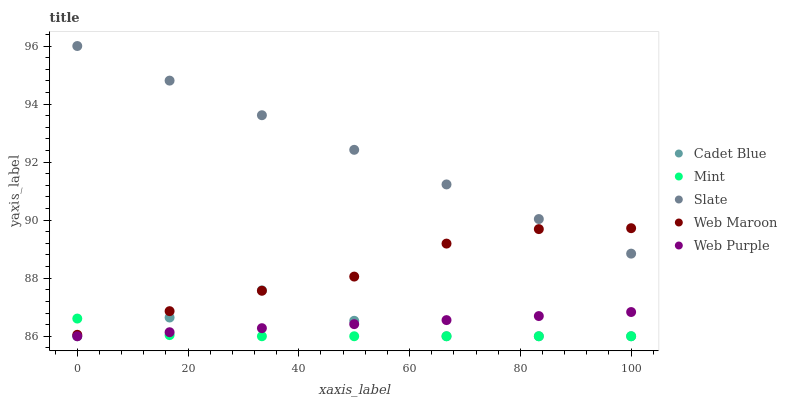Does Mint have the minimum area under the curve?
Answer yes or no. Yes. Does Slate have the maximum area under the curve?
Answer yes or no. Yes. Does Cadet Blue have the minimum area under the curve?
Answer yes or no. No. Does Cadet Blue have the maximum area under the curve?
Answer yes or no. No. Is Slate the smoothest?
Answer yes or no. Yes. Is Cadet Blue the roughest?
Answer yes or no. Yes. Is Cadet Blue the smoothest?
Answer yes or no. No. Is Slate the roughest?
Answer yes or no. No. Does Cadet Blue have the lowest value?
Answer yes or no. Yes. Does Slate have the lowest value?
Answer yes or no. No. Does Slate have the highest value?
Answer yes or no. Yes. Does Cadet Blue have the highest value?
Answer yes or no. No. Is Mint less than Slate?
Answer yes or no. Yes. Is Slate greater than Mint?
Answer yes or no. Yes. Does Cadet Blue intersect Web Purple?
Answer yes or no. Yes. Is Cadet Blue less than Web Purple?
Answer yes or no. No. Is Cadet Blue greater than Web Purple?
Answer yes or no. No. Does Mint intersect Slate?
Answer yes or no. No. 